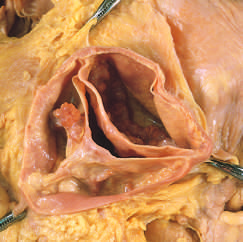how many cusps have a partial fusion at its center?
Answer the question using a single word or phrase. One 